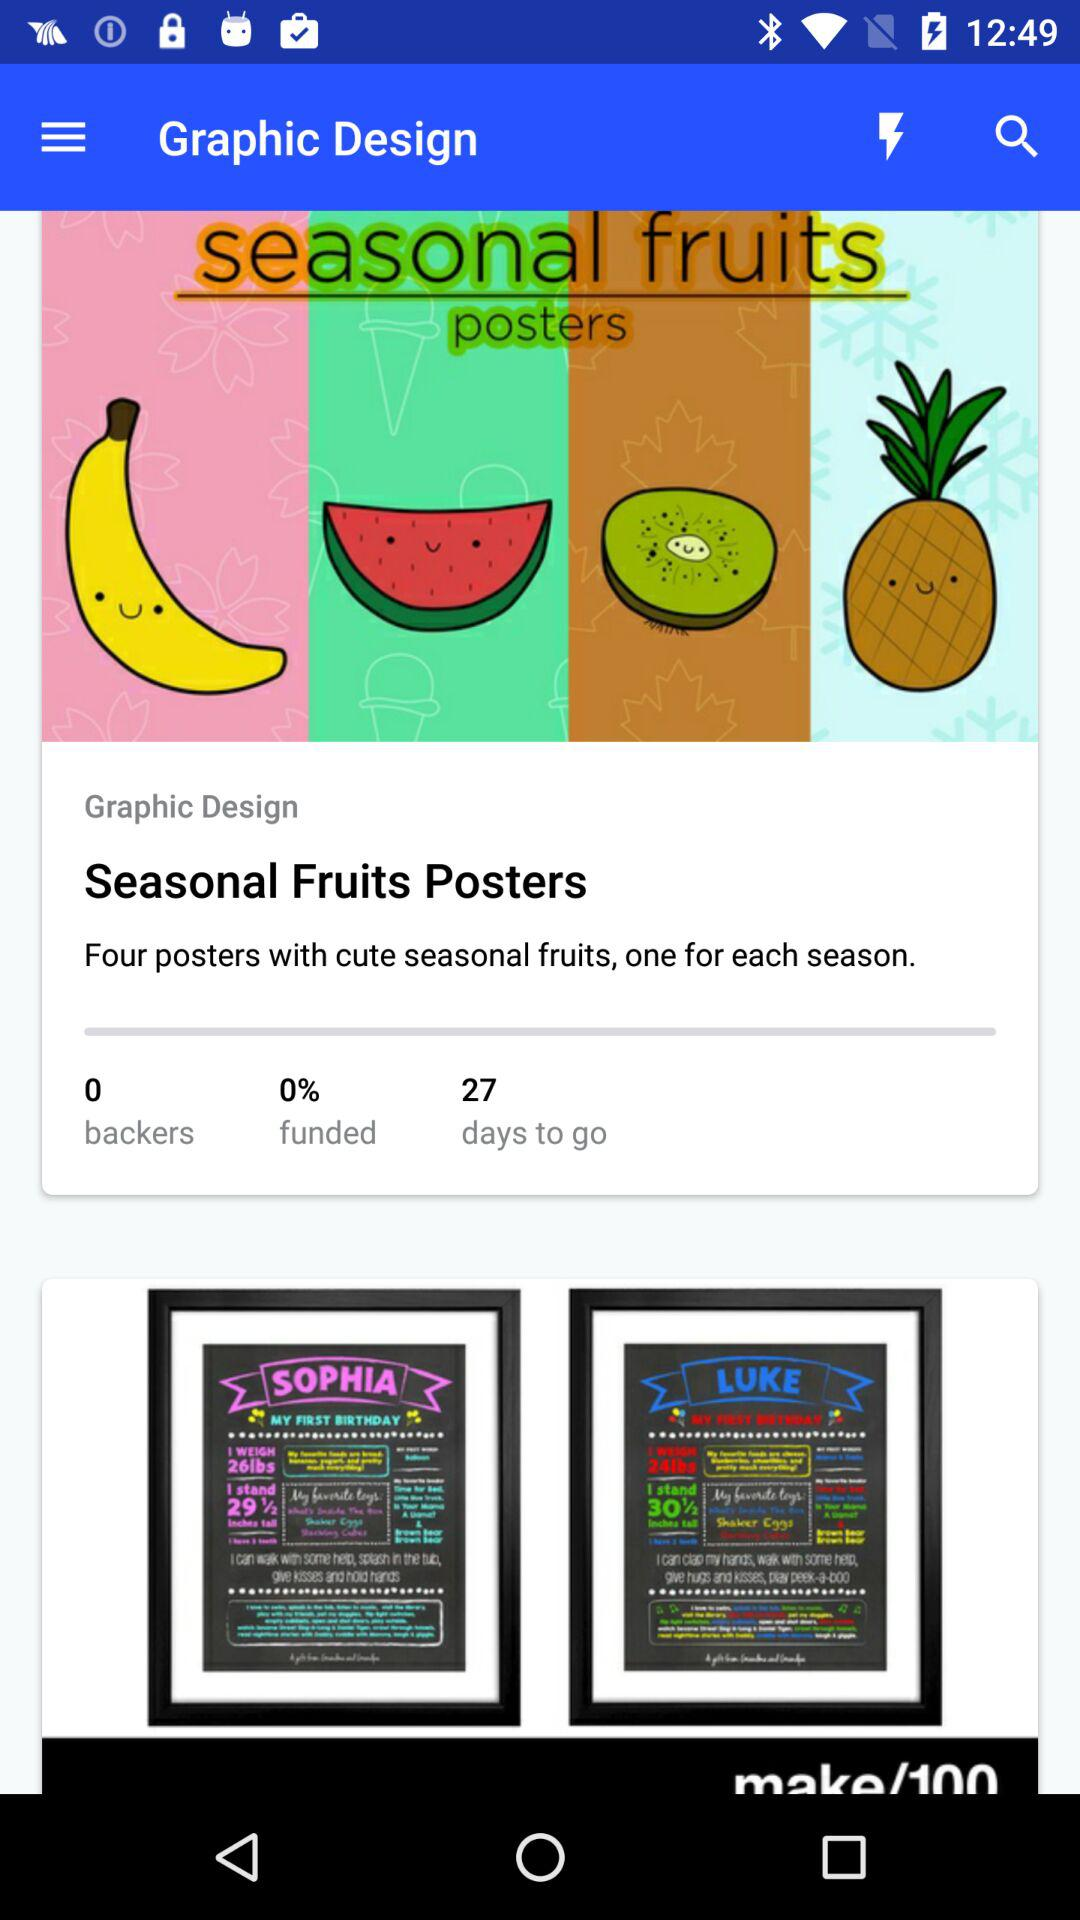How much percentage is funded?
Answer the question using a single word or phrase. The funded percentage is 0% 